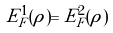Convert formula to latex. <formula><loc_0><loc_0><loc_500><loc_500>E _ { F } ^ { 1 } ( \rho ) = E _ { F } ^ { 2 } ( \rho )</formula> 